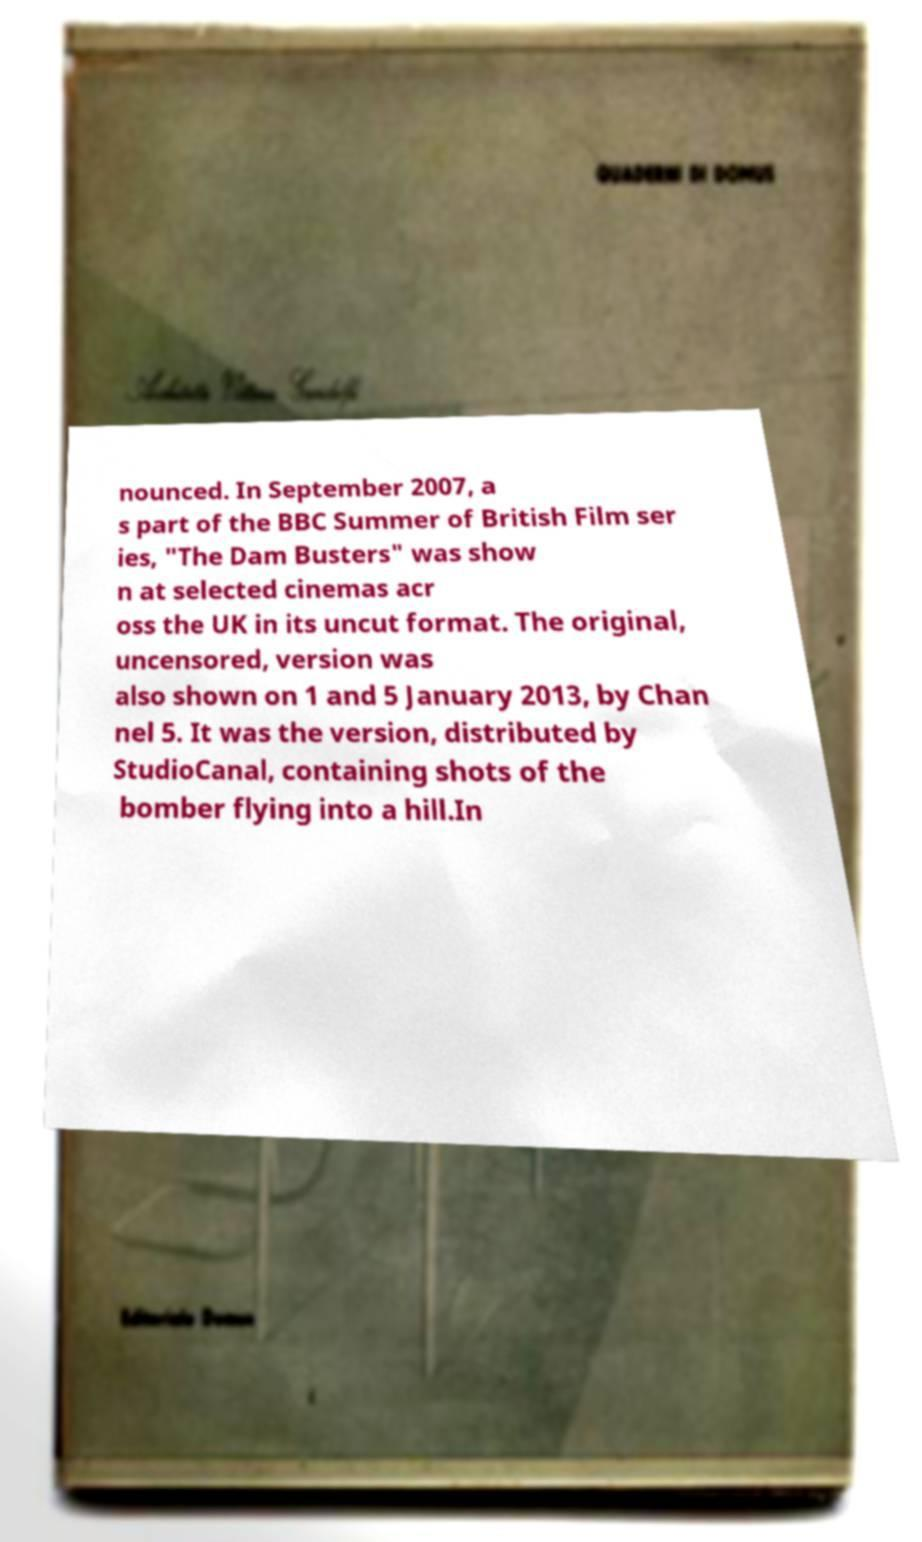Could you extract and type out the text from this image? nounced. In September 2007, a s part of the BBC Summer of British Film ser ies, "The Dam Busters" was show n at selected cinemas acr oss the UK in its uncut format. The original, uncensored, version was also shown on 1 and 5 January 2013, by Chan nel 5. It was the version, distributed by StudioCanal, containing shots of the bomber flying into a hill.In 